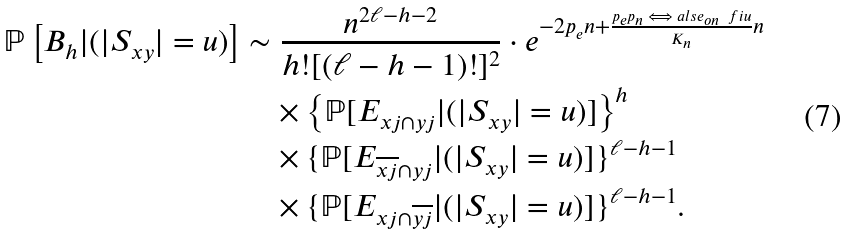Convert formula to latex. <formula><loc_0><loc_0><loc_500><loc_500>\mathbb { P } \left [ B _ { h } | ( | S _ { x y } | = u ) \right ] & \sim \frac { n ^ { 2 \ell - h - 2 } } { h ! [ ( \ell - h - 1 ) ! ] ^ { 2 } } \cdot e ^ { - 2 p _ { e } n + \frac { { p _ { e } p _ { n } \iff a l s e _ { o n } \ f i } u } { K _ { n } } n } \\ & \quad \times \left \{ \mathbb { P } [ E _ { { x } j \cap { y } j } | ( | S _ { x y } | = u ) ] \right \} ^ { h } \\ & \quad \times \{ \mathbb { P } [ E _ { \overline { { x } j } \cap { y } j } | ( | S _ { x y } | = u ) ] \} ^ { { \ell } - h - 1 } \\ & \quad \times \{ \mathbb { P } [ E _ { { x } j \cap { \overline { y j } } } | ( | S _ { x y } | = u ) ] \} ^ { { \ell } - h - 1 } .</formula> 